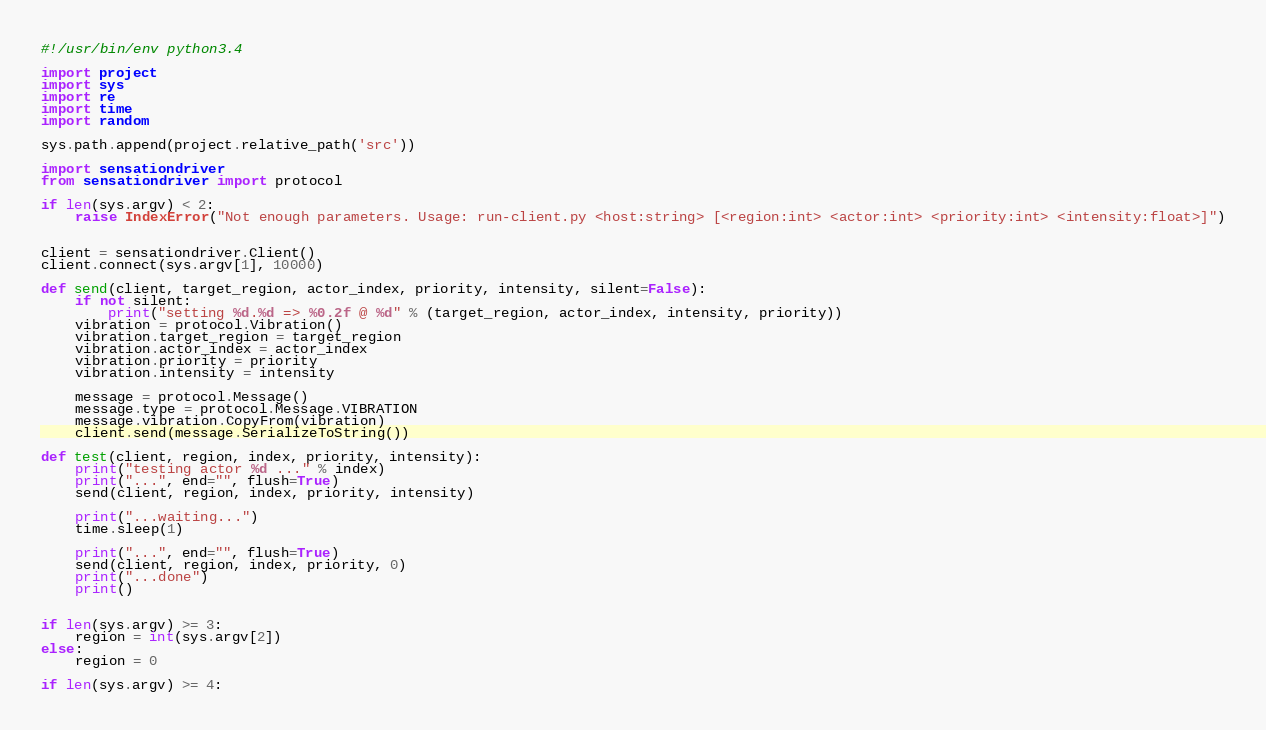<code> <loc_0><loc_0><loc_500><loc_500><_Python_>#!/usr/bin/env python3.4

import project
import sys
import re
import time
import random

sys.path.append(project.relative_path('src'))

import sensationdriver
from sensationdriver import protocol

if len(sys.argv) < 2:
    raise IndexError("Not enough parameters. Usage: run-client.py <host:string> [<region:int> <actor:int> <priority:int> <intensity:float>]")


client = sensationdriver.Client()
client.connect(sys.argv[1], 10000)

def send(client, target_region, actor_index, priority, intensity, silent=False):
    if not silent:
        print("setting %d.%d => %0.2f @ %d" % (target_region, actor_index, intensity, priority))
    vibration = protocol.Vibration()
    vibration.target_region = target_region
    vibration.actor_index = actor_index
    vibration.priority = priority
    vibration.intensity = intensity

    message = protocol.Message()
    message.type = protocol.Message.VIBRATION    
    message.vibration.CopyFrom(vibration)
    client.send(message.SerializeToString())

def test(client, region, index, priority, intensity):
    print("testing actor %d ..." % index)
    print("...", end="", flush=True)
    send(client, region, index, priority, intensity)

    print("...waiting...")
    time.sleep(1)

    print("...", end="", flush=True)
    send(client, region, index, priority, 0)
    print("...done")
    print()
    

if len(sys.argv) >= 3:
    region = int(sys.argv[2])
else:
    region = 0

if len(sys.argv) >= 4:</code> 